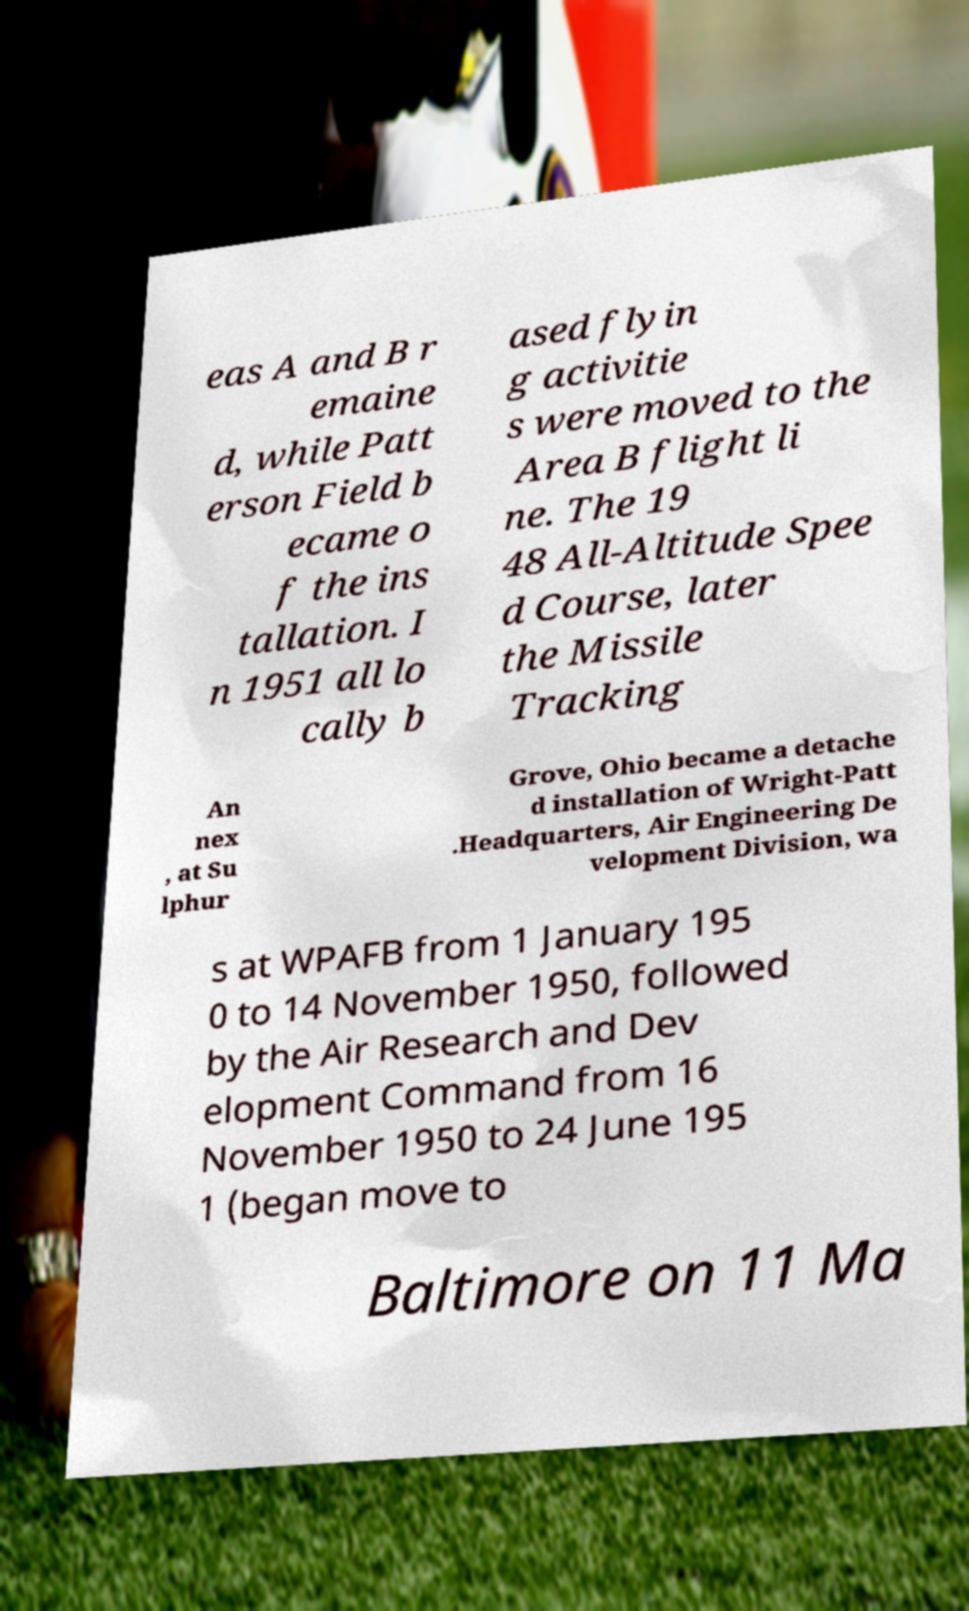Can you accurately transcribe the text from the provided image for me? eas A and B r emaine d, while Patt erson Field b ecame o f the ins tallation. I n 1951 all lo cally b ased flyin g activitie s were moved to the Area B flight li ne. The 19 48 All-Altitude Spee d Course, later the Missile Tracking An nex , at Su lphur Grove, Ohio became a detache d installation of Wright-Patt .Headquarters, Air Engineering De velopment Division, wa s at WPAFB from 1 January 195 0 to 14 November 1950, followed by the Air Research and Dev elopment Command from 16 November 1950 to 24 June 195 1 (began move to Baltimore on 11 Ma 